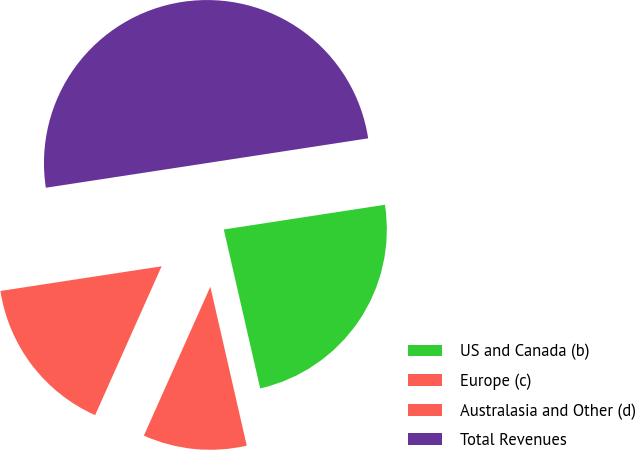Convert chart to OTSL. <chart><loc_0><loc_0><loc_500><loc_500><pie_chart><fcel>US and Canada (b)<fcel>Europe (c)<fcel>Australasia and Other (d)<fcel>Total Revenues<nl><fcel>23.84%<fcel>10.27%<fcel>15.9%<fcel>50.0%<nl></chart> 